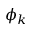Convert formula to latex. <formula><loc_0><loc_0><loc_500><loc_500>\phi _ { k }</formula> 